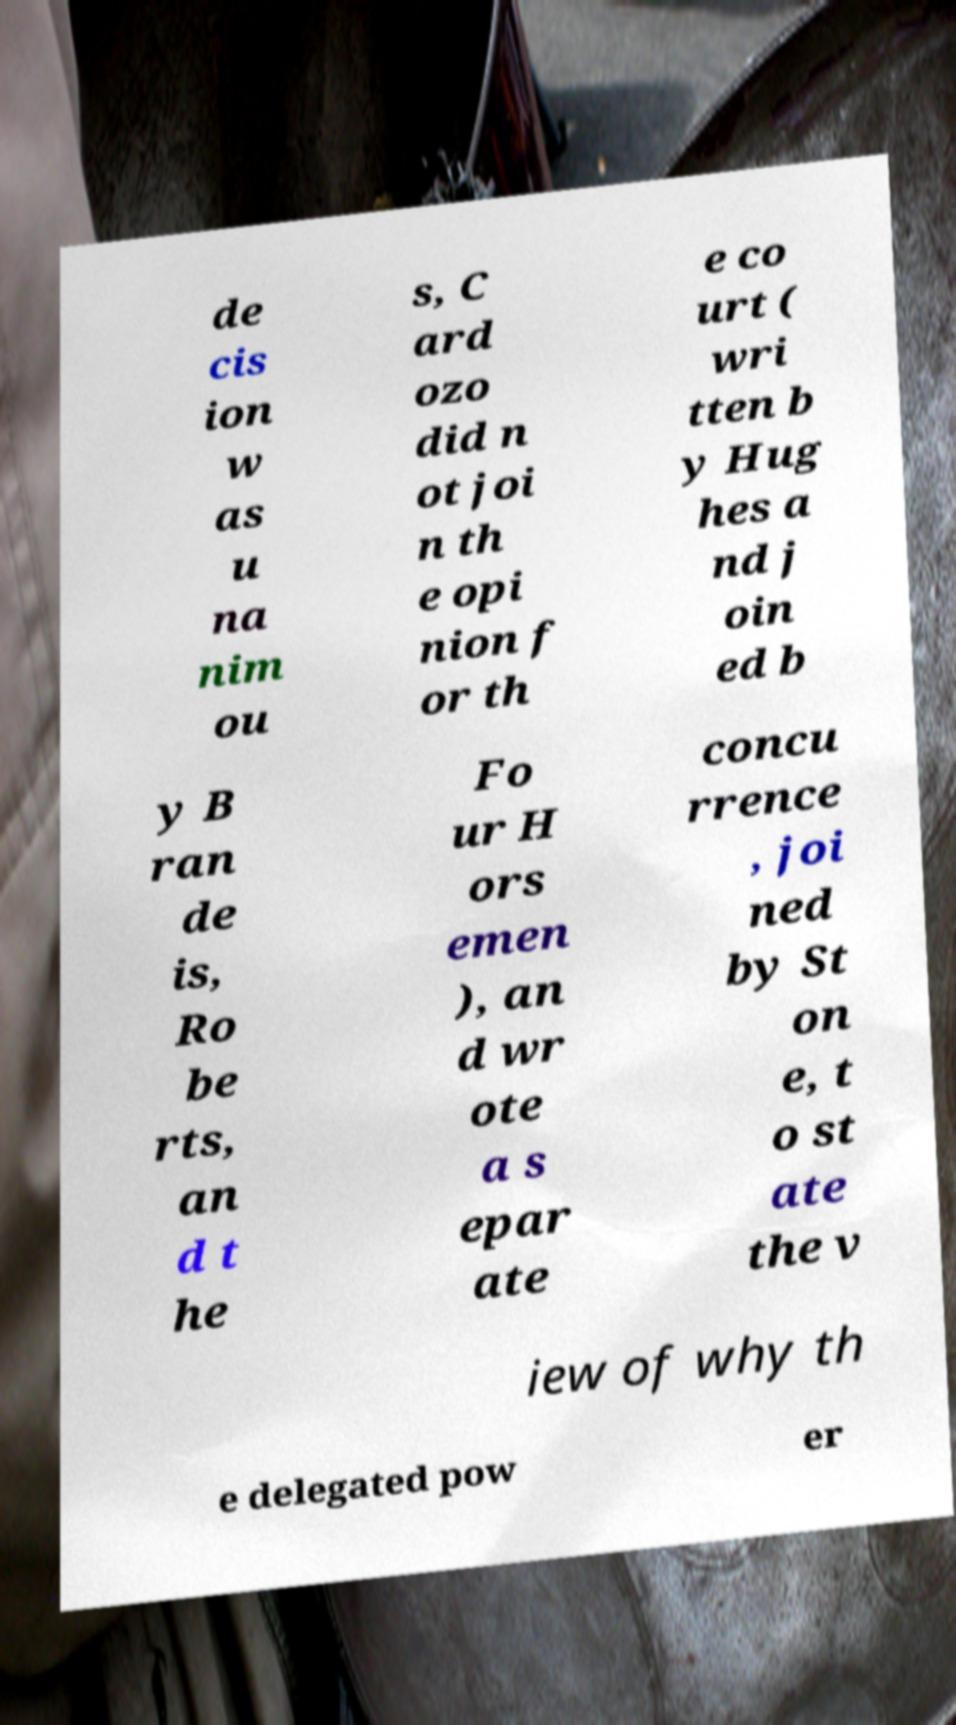Can you accurately transcribe the text from the provided image for me? de cis ion w as u na nim ou s, C ard ozo did n ot joi n th e opi nion f or th e co urt ( wri tten b y Hug hes a nd j oin ed b y B ran de is, Ro be rts, an d t he Fo ur H ors emen ), an d wr ote a s epar ate concu rrence , joi ned by St on e, t o st ate the v iew of why th e delegated pow er 